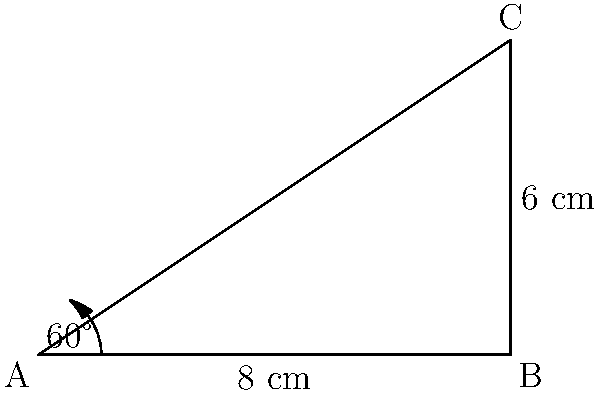In the children's ward of the hospital, there's a triangular sign for the play area. If two sides of this sign measure 8 cm and 6 cm, with an angle of 60° between them, what is the area of the sign? (Round your answer to the nearest square centimeter.) Let's solve this step-by-step:

1) We can use the formula for the area of a triangle when we know two sides and the included angle:

   $$ A = \frac{1}{2} ab \sin C $$

   Where $A$ is the area, $a$ and $b$ are the known sides, and $C$ is the known angle.

2) We have:
   $a = 8$ cm
   $b = 6$ cm
   $C = 60°$

3) Let's substitute these into our formula:

   $$ A = \frac{1}{2} \cdot 8 \cdot 6 \cdot \sin 60° $$

4) We know that $\sin 60° = \frac{\sqrt{3}}{2}$, so:

   $$ A = \frac{1}{2} \cdot 8 \cdot 6 \cdot \frac{\sqrt{3}}{2} $$

5) Let's simplify:

   $$ A = 24 \cdot \frac{\sqrt{3}}{2} = 12\sqrt{3} $$

6) To calculate this:
   $12\sqrt{3} \approx 20.78$ cm²

7) Rounding to the nearest square centimeter:
   $20.78$ cm² ≈ 21 cm²
Answer: 21 cm² 